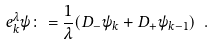Convert formula to latex. <formula><loc_0><loc_0><loc_500><loc_500>e ^ { \lambda } _ { k } \psi \colon = \frac { 1 } { \lambda } ( D _ { - } \psi _ { k } + D _ { + } \psi _ { k - 1 } ) \ .</formula> 